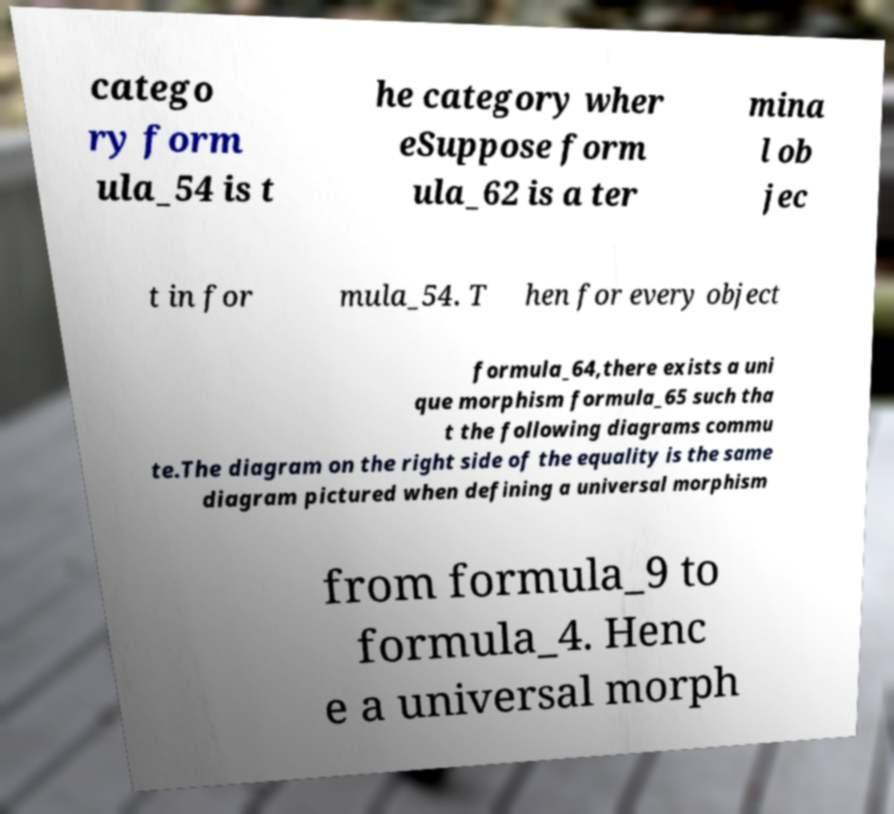Can you accurately transcribe the text from the provided image for me? catego ry form ula_54 is t he category wher eSuppose form ula_62 is a ter mina l ob jec t in for mula_54. T hen for every object formula_64,there exists a uni que morphism formula_65 such tha t the following diagrams commu te.The diagram on the right side of the equality is the same diagram pictured when defining a universal morphism from formula_9 to formula_4. Henc e a universal morph 